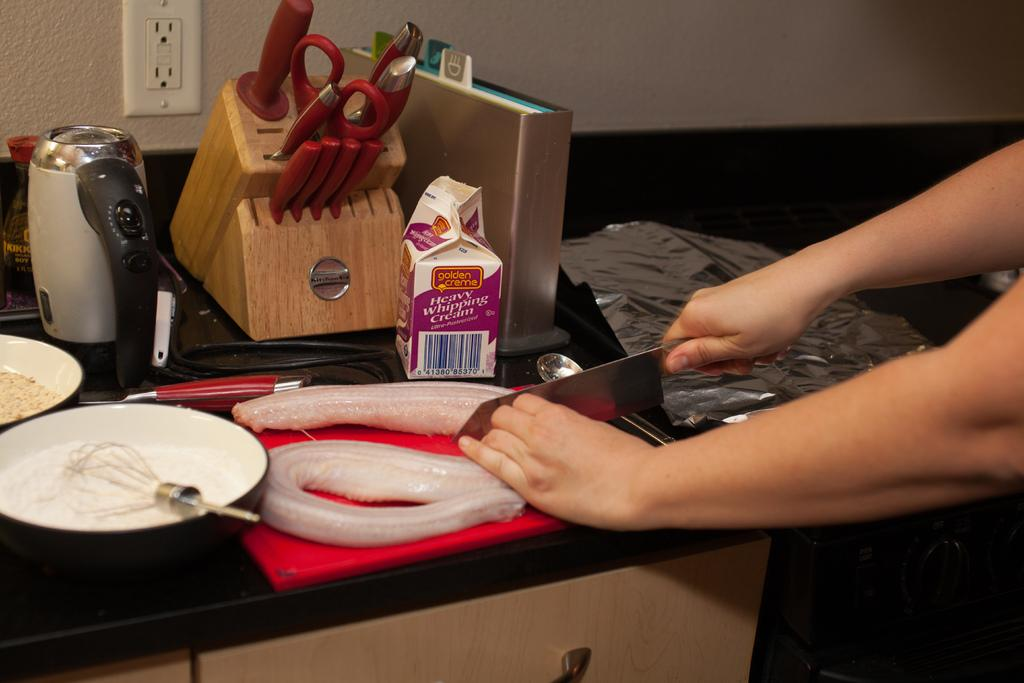<image>
Write a terse but informative summary of the picture. A person cutting food next to a carton of Heavy Whipping Cream on a cutting board in a kitchen. 